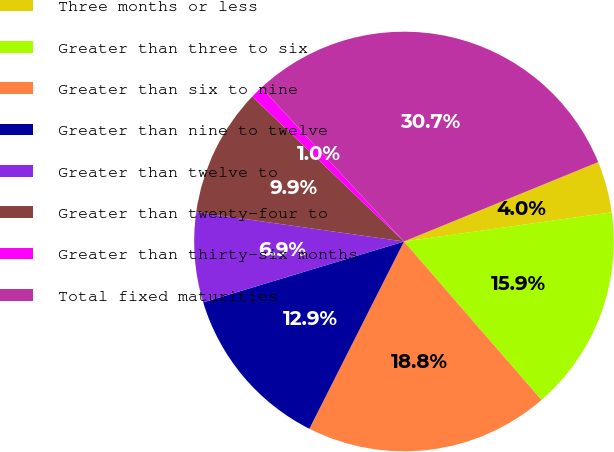Convert chart. <chart><loc_0><loc_0><loc_500><loc_500><pie_chart><fcel>Three months or less<fcel>Greater than three to six<fcel>Greater than six to nine<fcel>Greater than nine to twelve<fcel>Greater than twelve to<fcel>Greater than twenty-four to<fcel>Greater than thirty-six months<fcel>Total fixed maturities<nl><fcel>3.95%<fcel>15.85%<fcel>18.82%<fcel>12.87%<fcel>6.92%<fcel>9.9%<fcel>0.97%<fcel>30.72%<nl></chart> 